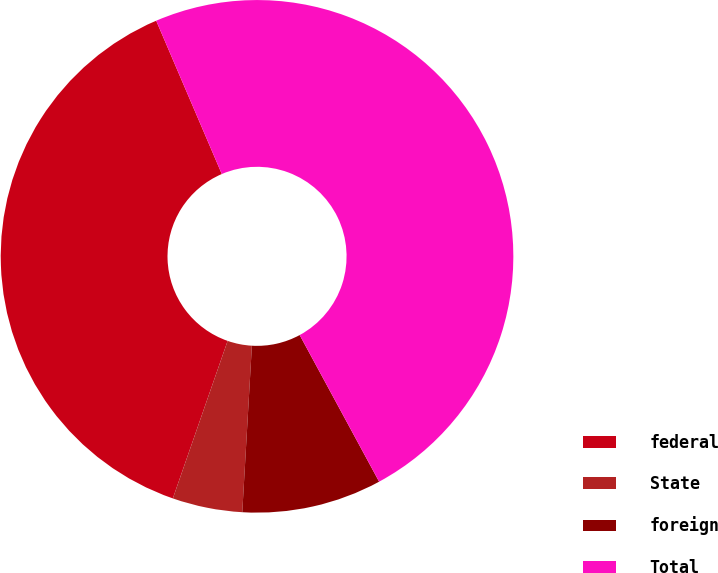<chart> <loc_0><loc_0><loc_500><loc_500><pie_chart><fcel>federal<fcel>State<fcel>foreign<fcel>Total<nl><fcel>38.24%<fcel>4.41%<fcel>8.82%<fcel>48.54%<nl></chart> 